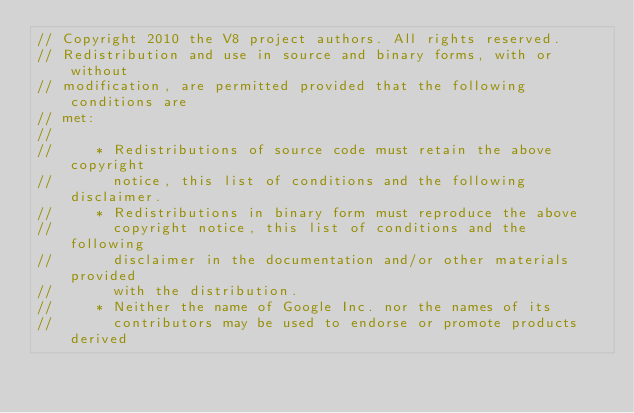Convert code to text. <code><loc_0><loc_0><loc_500><loc_500><_C++_>// Copyright 2010 the V8 project authors. All rights reserved.
// Redistribution and use in source and binary forms, with or without
// modification, are permitted provided that the following conditions are
// met:
//
//     * Redistributions of source code must retain the above copyright
//       notice, this list of conditions and the following disclaimer.
//     * Redistributions in binary form must reproduce the above
//       copyright notice, this list of conditions and the following
//       disclaimer in the documentation and/or other materials provided
//       with the distribution.
//     * Neither the name of Google Inc. nor the names of its
//       contributors may be used to endorse or promote products derived</code> 